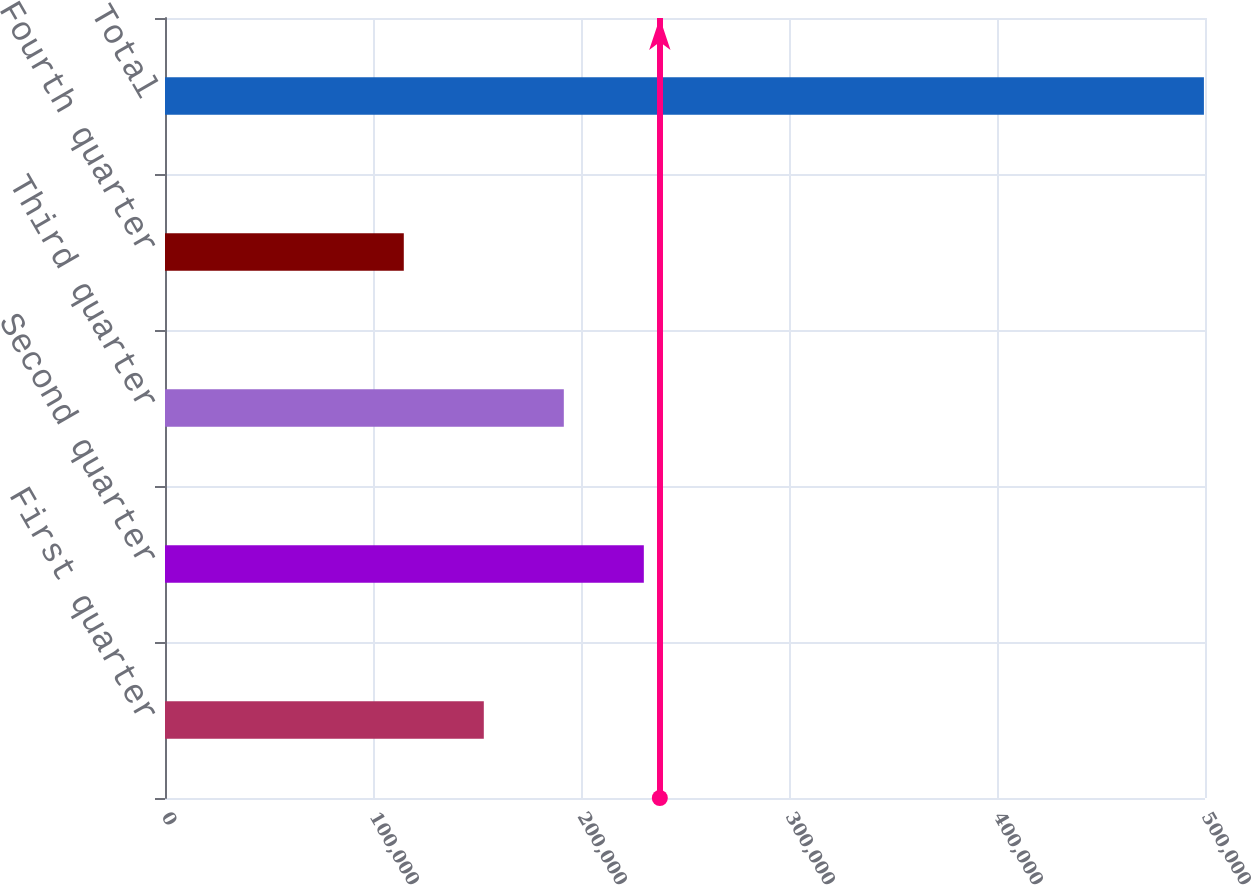<chart> <loc_0><loc_0><loc_500><loc_500><bar_chart><fcel>First quarter<fcel>Second quarter<fcel>Third quarter<fcel>Fourth quarter<fcel>Total<nl><fcel>153272<fcel>230207<fcel>191740<fcel>114805<fcel>499478<nl></chart> 